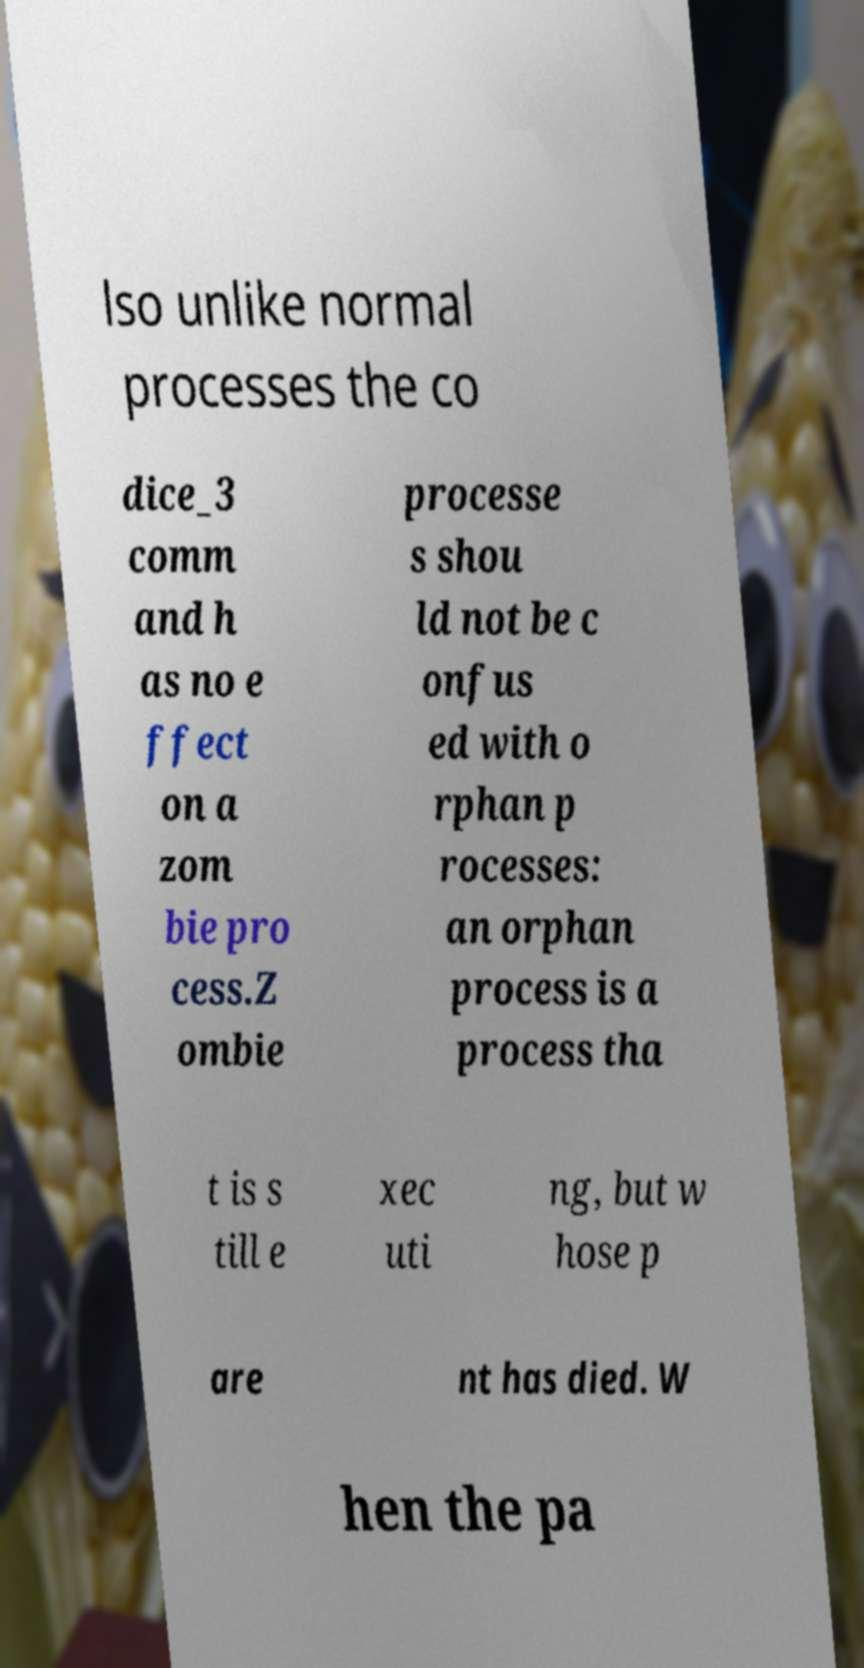Please read and relay the text visible in this image. What does it say? lso unlike normal processes the co dice_3 comm and h as no e ffect on a zom bie pro cess.Z ombie processe s shou ld not be c onfus ed with o rphan p rocesses: an orphan process is a process tha t is s till e xec uti ng, but w hose p are nt has died. W hen the pa 